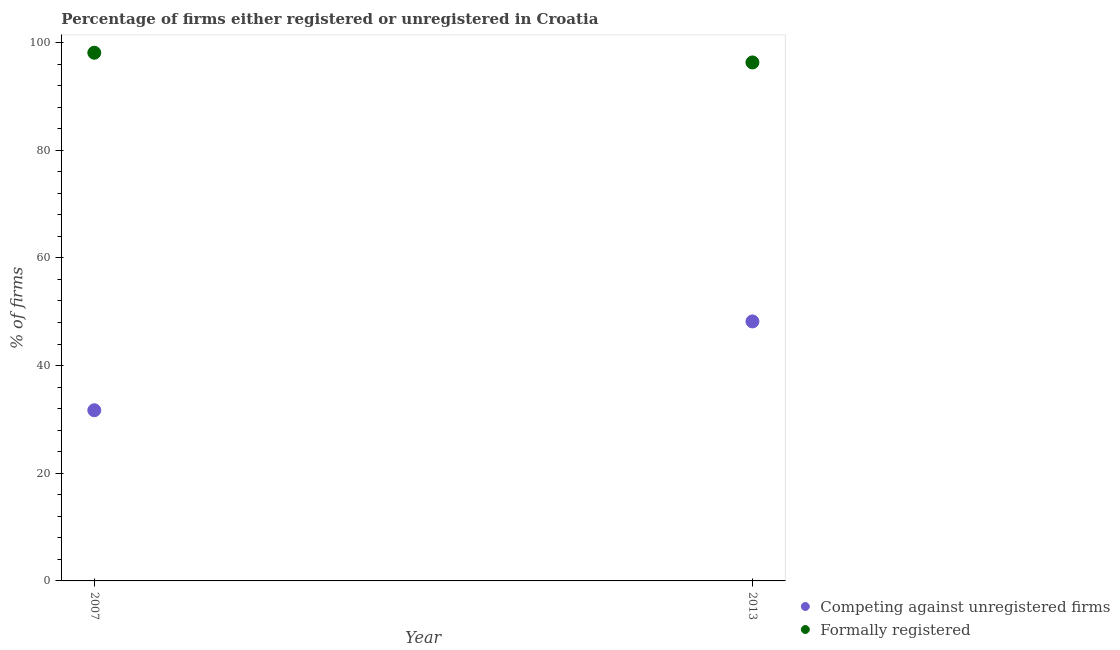What is the percentage of registered firms in 2007?
Give a very brief answer. 31.7. Across all years, what is the maximum percentage of formally registered firms?
Keep it short and to the point. 98.1. Across all years, what is the minimum percentage of registered firms?
Ensure brevity in your answer.  31.7. In which year was the percentage of formally registered firms maximum?
Offer a very short reply. 2007. What is the total percentage of registered firms in the graph?
Your answer should be compact. 79.9. What is the difference between the percentage of registered firms in 2007 and that in 2013?
Give a very brief answer. -16.5. What is the difference between the percentage of formally registered firms in 2007 and the percentage of registered firms in 2013?
Your answer should be very brief. 49.9. What is the average percentage of registered firms per year?
Ensure brevity in your answer.  39.95. In the year 2013, what is the difference between the percentage of formally registered firms and percentage of registered firms?
Give a very brief answer. 48.1. In how many years, is the percentage of formally registered firms greater than 36 %?
Provide a succinct answer. 2. What is the ratio of the percentage of formally registered firms in 2007 to that in 2013?
Your answer should be very brief. 1.02. In how many years, is the percentage of formally registered firms greater than the average percentage of formally registered firms taken over all years?
Offer a very short reply. 1. Does the percentage of registered firms monotonically increase over the years?
Offer a very short reply. Yes. How many dotlines are there?
Make the answer very short. 2. How many years are there in the graph?
Offer a terse response. 2. Does the graph contain grids?
Make the answer very short. No. Where does the legend appear in the graph?
Your answer should be very brief. Bottom right. How are the legend labels stacked?
Make the answer very short. Vertical. What is the title of the graph?
Keep it short and to the point. Percentage of firms either registered or unregistered in Croatia. Does "Exports of goods" appear as one of the legend labels in the graph?
Make the answer very short. No. What is the label or title of the X-axis?
Ensure brevity in your answer.  Year. What is the label or title of the Y-axis?
Your response must be concise. % of firms. What is the % of firms in Competing against unregistered firms in 2007?
Give a very brief answer. 31.7. What is the % of firms of Formally registered in 2007?
Provide a short and direct response. 98.1. What is the % of firms in Competing against unregistered firms in 2013?
Ensure brevity in your answer.  48.2. What is the % of firms of Formally registered in 2013?
Offer a very short reply. 96.3. Across all years, what is the maximum % of firms in Competing against unregistered firms?
Ensure brevity in your answer.  48.2. Across all years, what is the maximum % of firms in Formally registered?
Provide a short and direct response. 98.1. Across all years, what is the minimum % of firms in Competing against unregistered firms?
Offer a very short reply. 31.7. Across all years, what is the minimum % of firms of Formally registered?
Keep it short and to the point. 96.3. What is the total % of firms of Competing against unregistered firms in the graph?
Ensure brevity in your answer.  79.9. What is the total % of firms of Formally registered in the graph?
Offer a terse response. 194.4. What is the difference between the % of firms of Competing against unregistered firms in 2007 and that in 2013?
Give a very brief answer. -16.5. What is the difference between the % of firms in Formally registered in 2007 and that in 2013?
Give a very brief answer. 1.8. What is the difference between the % of firms of Competing against unregistered firms in 2007 and the % of firms of Formally registered in 2013?
Give a very brief answer. -64.6. What is the average % of firms in Competing against unregistered firms per year?
Make the answer very short. 39.95. What is the average % of firms of Formally registered per year?
Make the answer very short. 97.2. In the year 2007, what is the difference between the % of firms of Competing against unregistered firms and % of firms of Formally registered?
Offer a terse response. -66.4. In the year 2013, what is the difference between the % of firms in Competing against unregistered firms and % of firms in Formally registered?
Provide a succinct answer. -48.1. What is the ratio of the % of firms of Competing against unregistered firms in 2007 to that in 2013?
Give a very brief answer. 0.66. What is the ratio of the % of firms of Formally registered in 2007 to that in 2013?
Your response must be concise. 1.02. What is the difference between the highest and the lowest % of firms in Formally registered?
Your answer should be very brief. 1.8. 